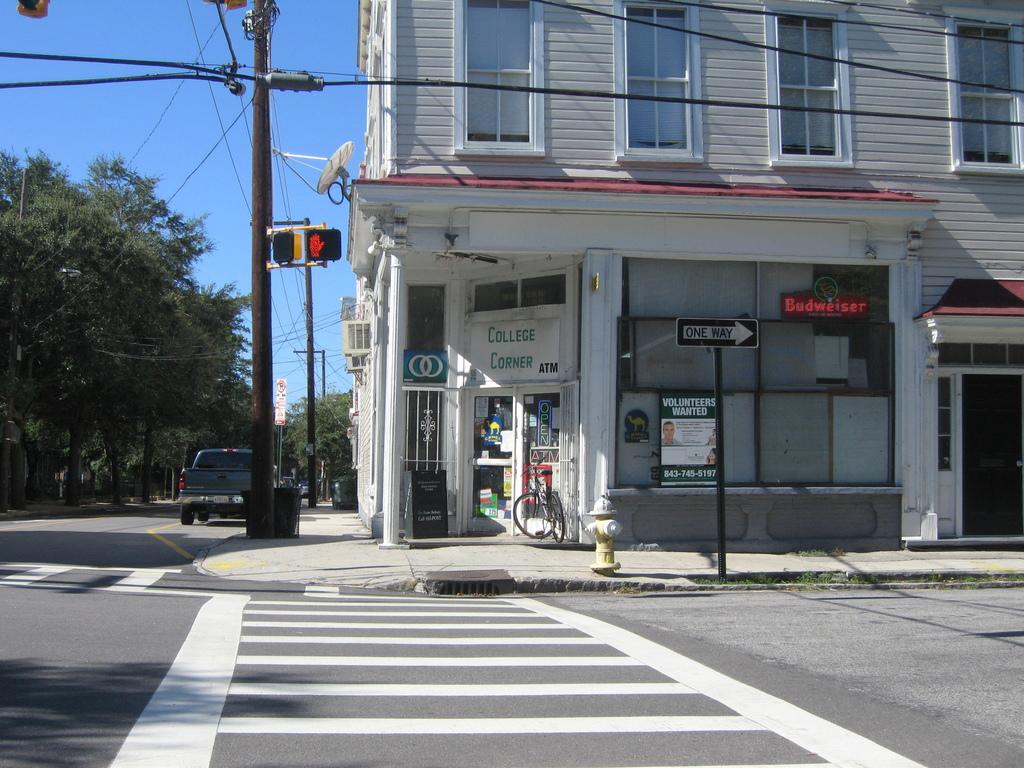Provide a one-sentence caption for the provided image. The college corner store has an ATM and has a license to sell beers like Budweiser. 